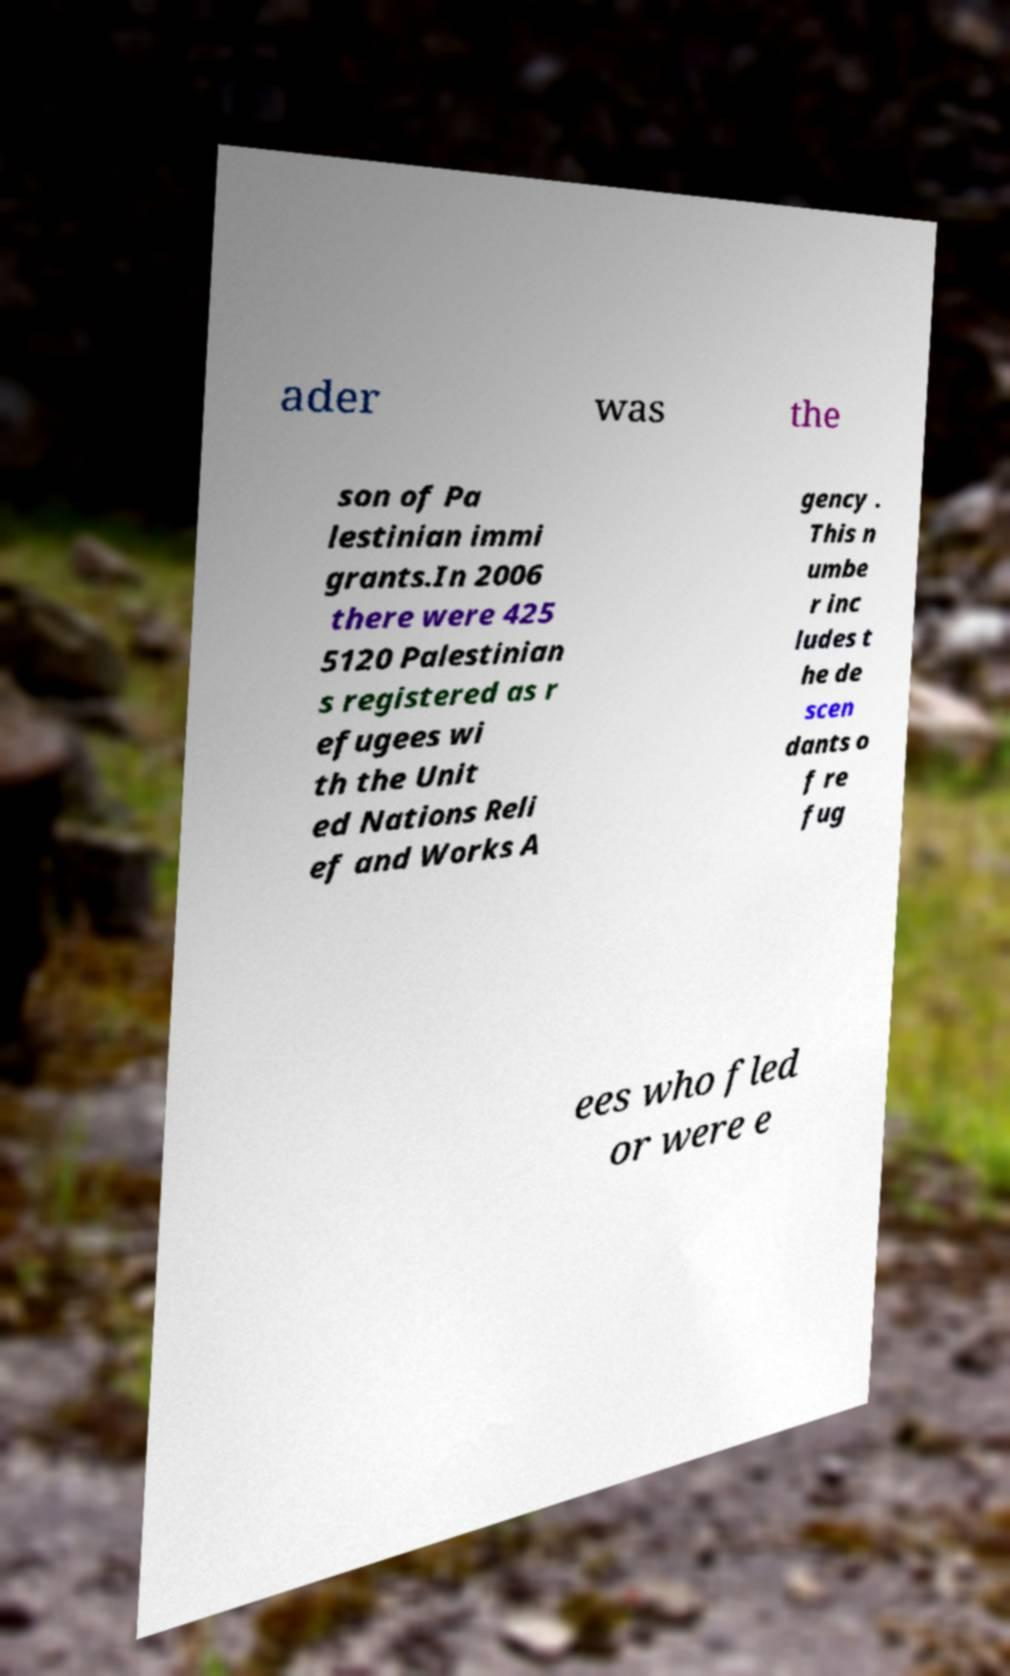What messages or text are displayed in this image? I need them in a readable, typed format. ader was the son of Pa lestinian immi grants.In 2006 there were 425 5120 Palestinian s registered as r efugees wi th the Unit ed Nations Reli ef and Works A gency . This n umbe r inc ludes t he de scen dants o f re fug ees who fled or were e 